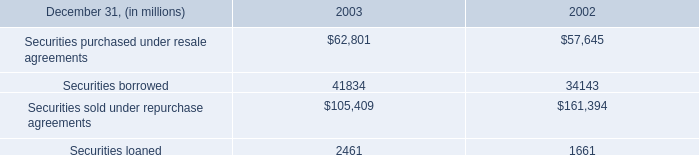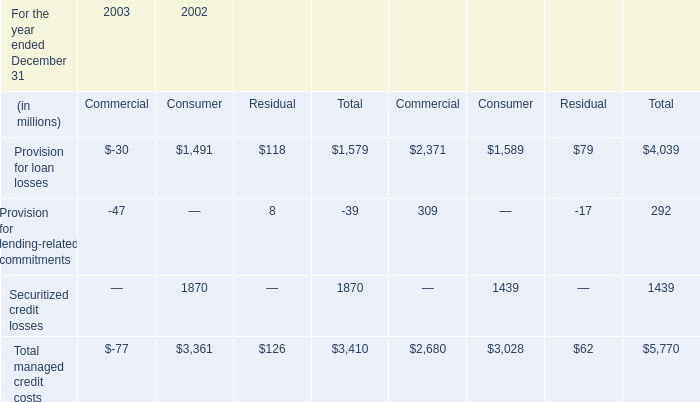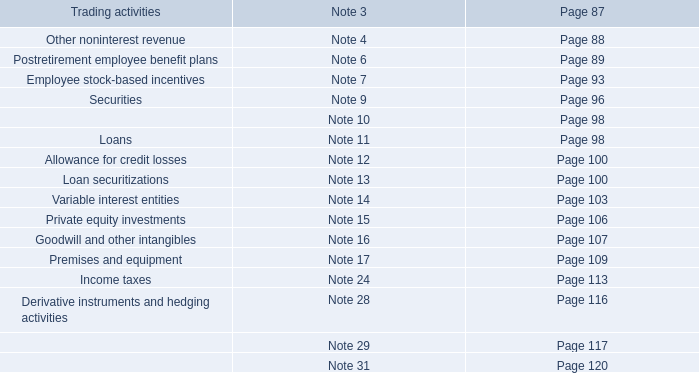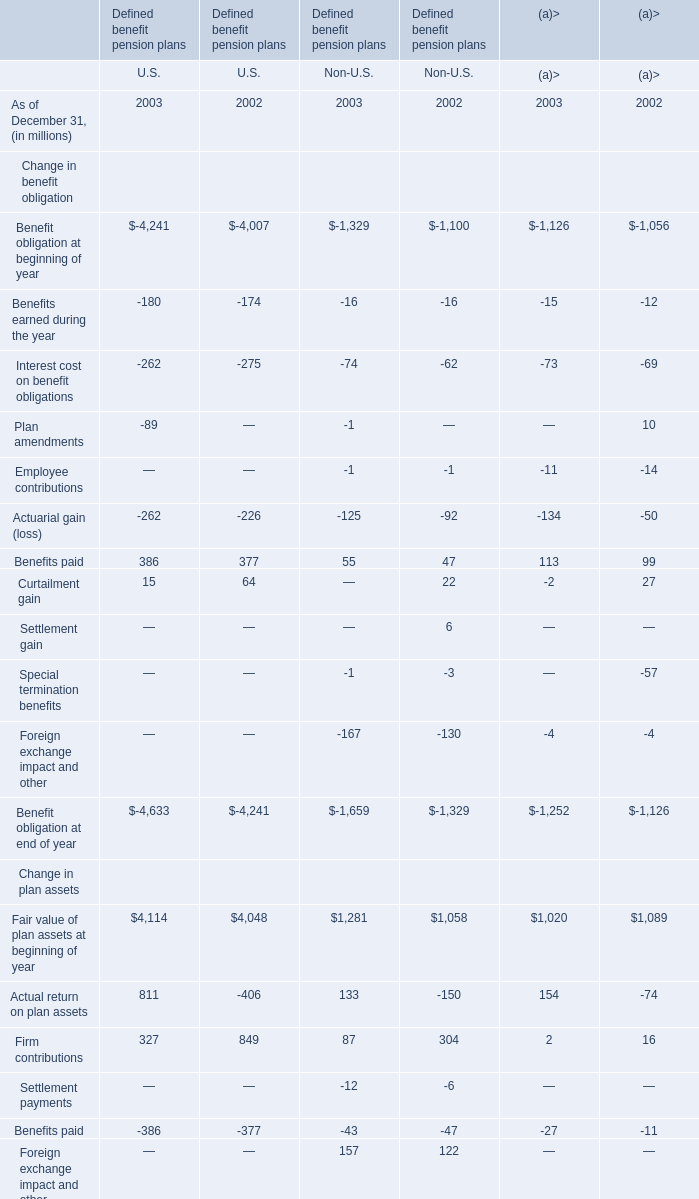What's the sum of all Reconciliation of funded status of U.S that are greater than 1000 in 2002? (in millions) 
Answer: 1224. 